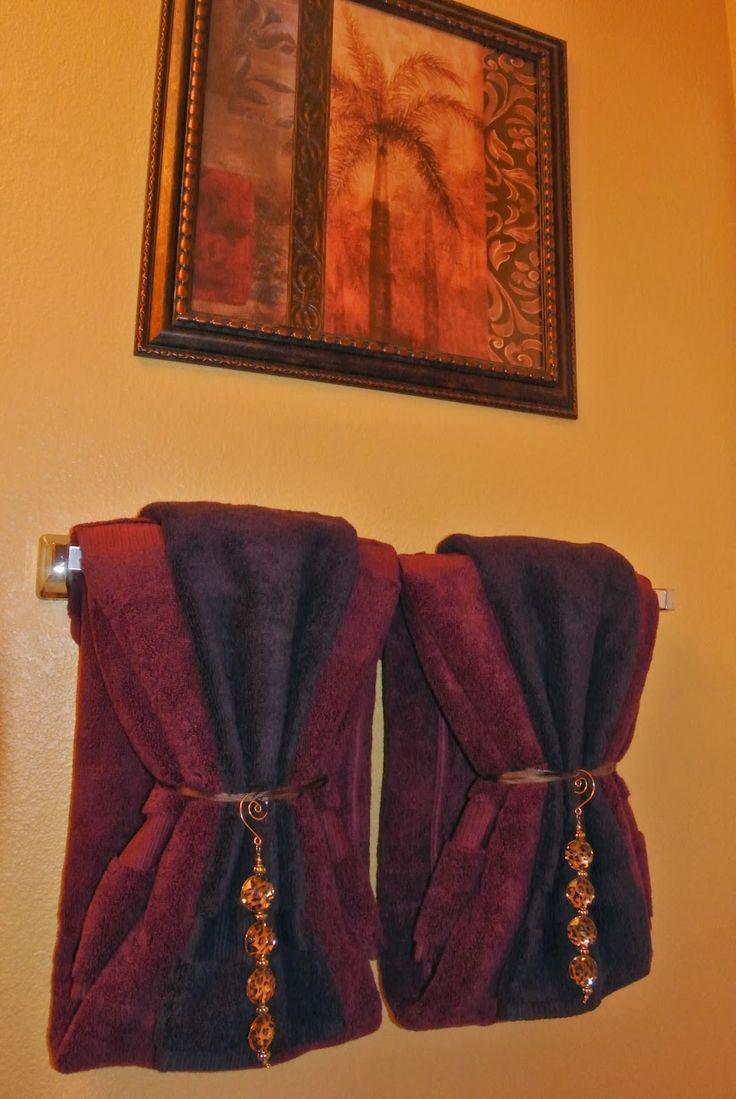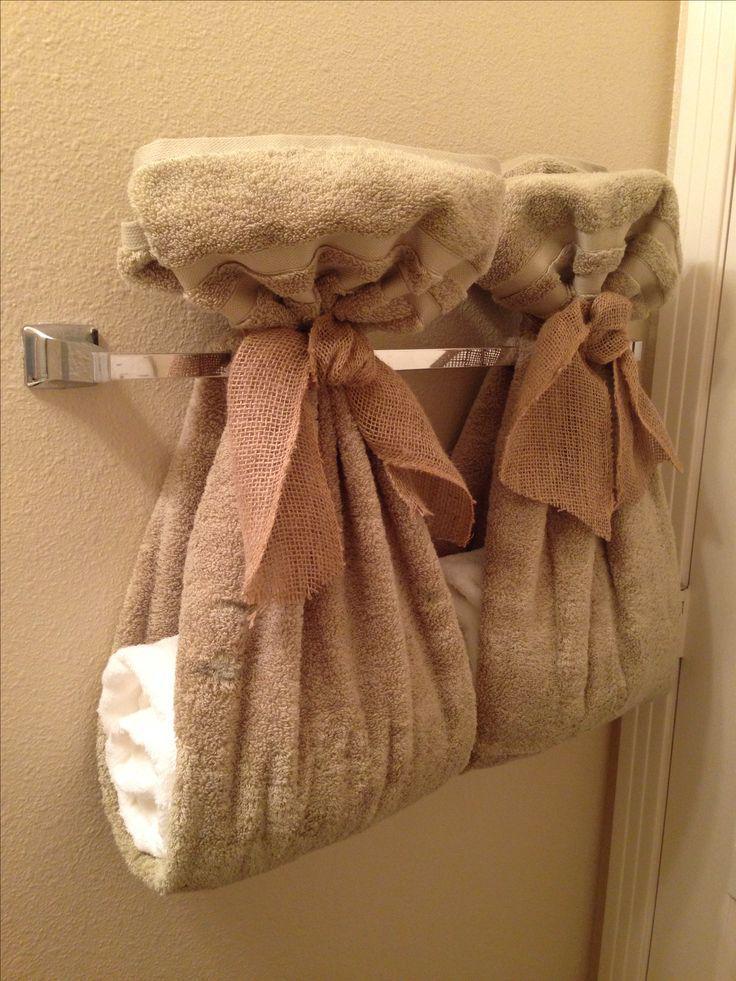The first image is the image on the left, the second image is the image on the right. For the images shown, is this caption "Right image features side-by-side towels arranged decoratively on a bar." true? Answer yes or no. Yes. The first image is the image on the left, the second image is the image on the right. Assess this claim about the two images: "A picture is hanging on the wall above some towels.". Correct or not? Answer yes or no. Yes. 